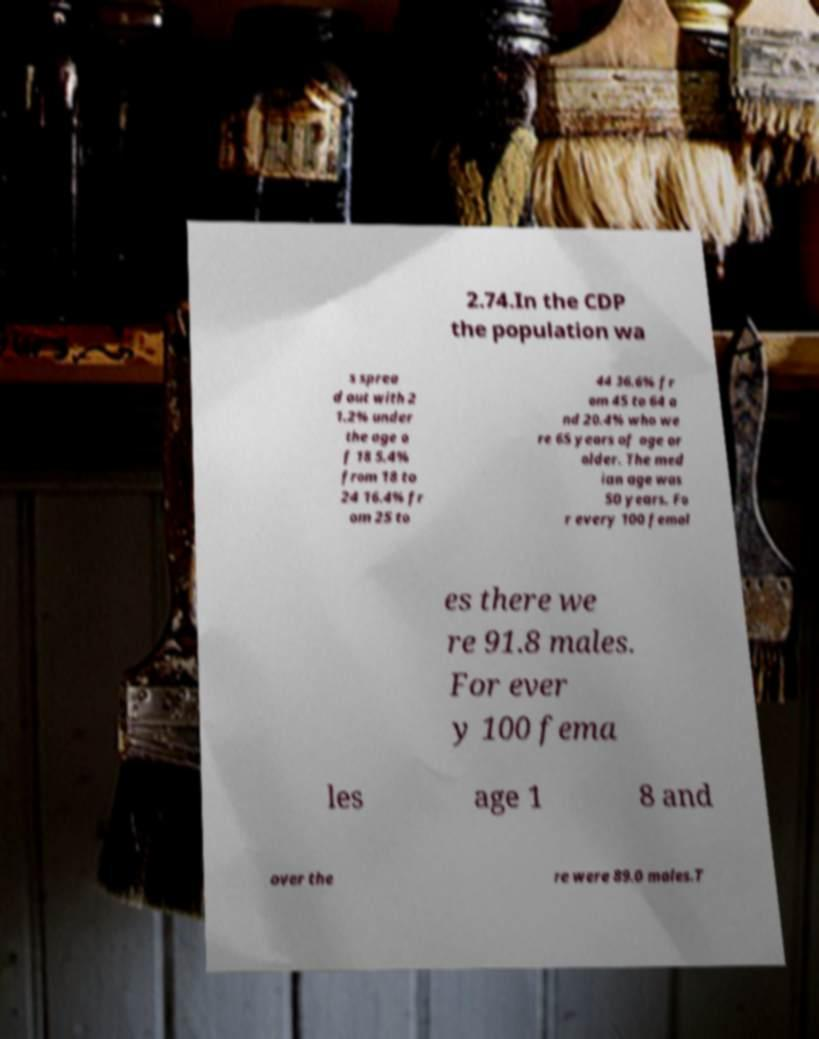What messages or text are displayed in this image? I need them in a readable, typed format. 2.74.In the CDP the population wa s sprea d out with 2 1.2% under the age o f 18 5.4% from 18 to 24 16.4% fr om 25 to 44 36.6% fr om 45 to 64 a nd 20.4% who we re 65 years of age or older. The med ian age was 50 years. Fo r every 100 femal es there we re 91.8 males. For ever y 100 fema les age 1 8 and over the re were 89.0 males.T 